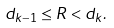Convert formula to latex. <formula><loc_0><loc_0><loc_500><loc_500>d _ { k - 1 } \leq R < d _ { k } .</formula> 